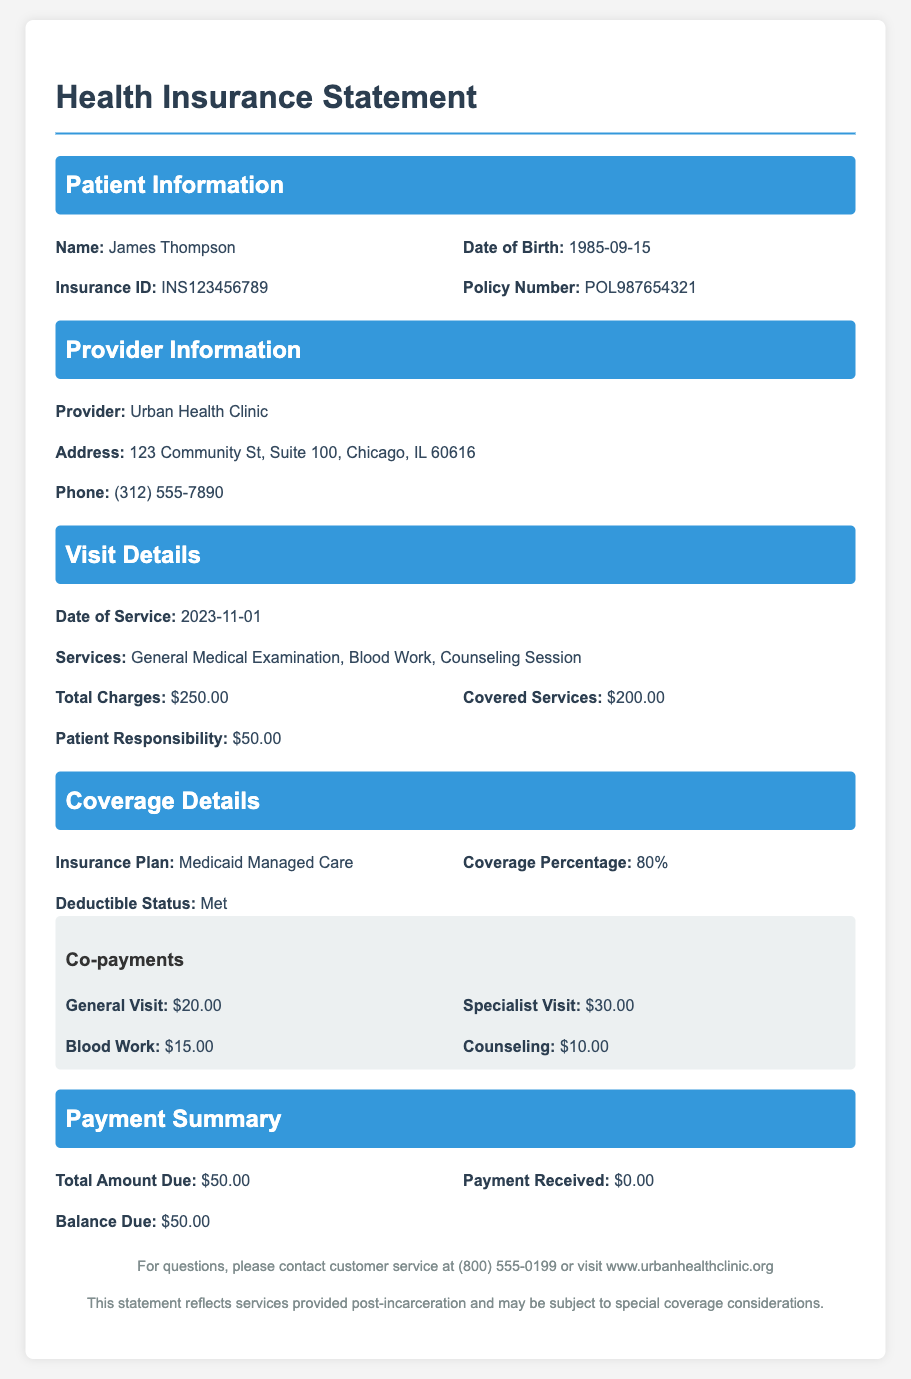What is the name of the patient? The patient's name is listed at the top of the document under Patient Information.
Answer: James Thompson What is the date of service? The date of service is mentioned in the Visit Details section of the document.
Answer: 2023-11-01 What is the total amount due? The total amount due is specified in the Payment Summary section, indicating what the patient needs to pay.
Answer: $50.00 What percentage of coverage does the insurance plan provide? The Coverage Details section indicates the percentage of coverage the insurance plan offers.
Answer: 80% How much is the co-payment for a counseling session? The co-payment for a counseling session is listed in the Co-payments subsection under Coverage Details.
Answer: $10.00 What provider did the patient visit? The provider's name is provided in the Provider Information section of the document.
Answer: Urban Health Clinic What services were received during the visit? The services received are outlined in the Visit Details section, detailing what the patient underwent.
Answer: General Medical Examination, Blood Work, Counseling Session What is the patient's responsibility after insurance coverage? The patient responsibility amount is stated in the Visit Details section, showing what the patient needs to pay after insurance.
Answer: $50.00 What is the address of the healthcare provider? The address of the provider is included in the Provider Information section of the document.
Answer: 123 Community St, Suite 100, Chicago, IL 60616 